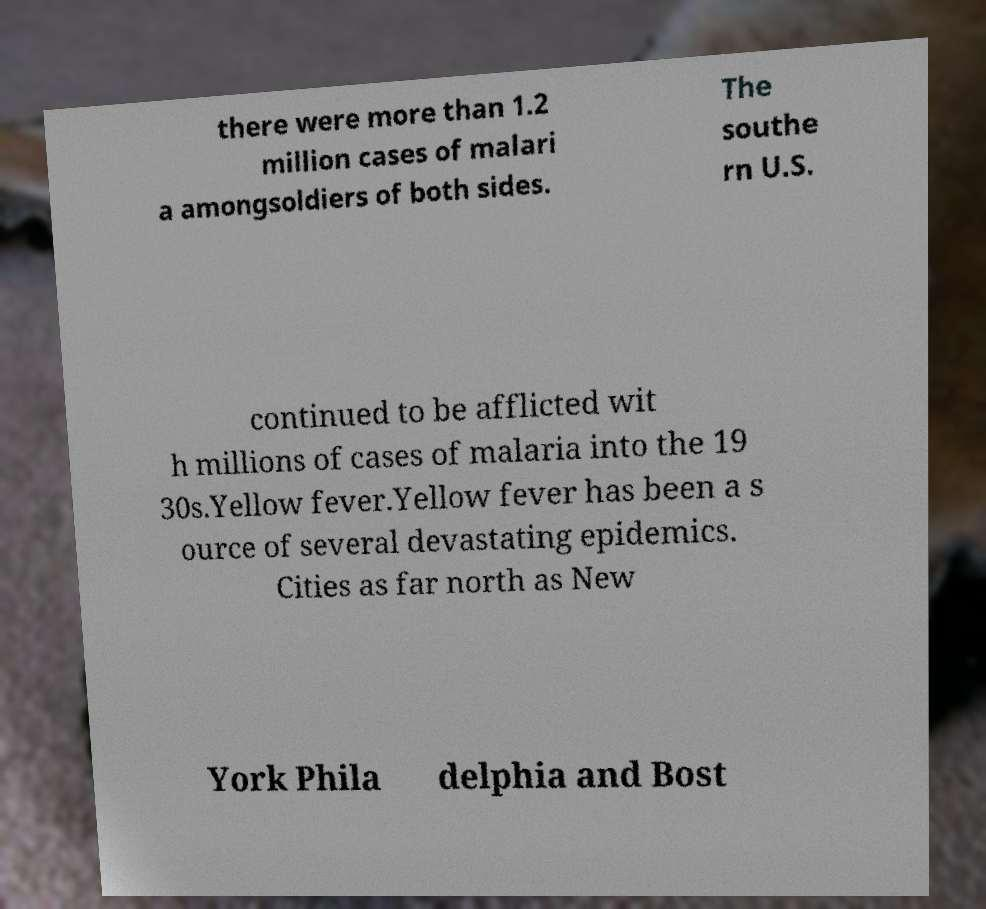Could you extract and type out the text from this image? there were more than 1.2 million cases of malari a amongsoldiers of both sides. The southe rn U.S. continued to be afflicted wit h millions of cases of malaria into the 19 30s.Yellow fever.Yellow fever has been a s ource of several devastating epidemics. Cities as far north as New York Phila delphia and Bost 